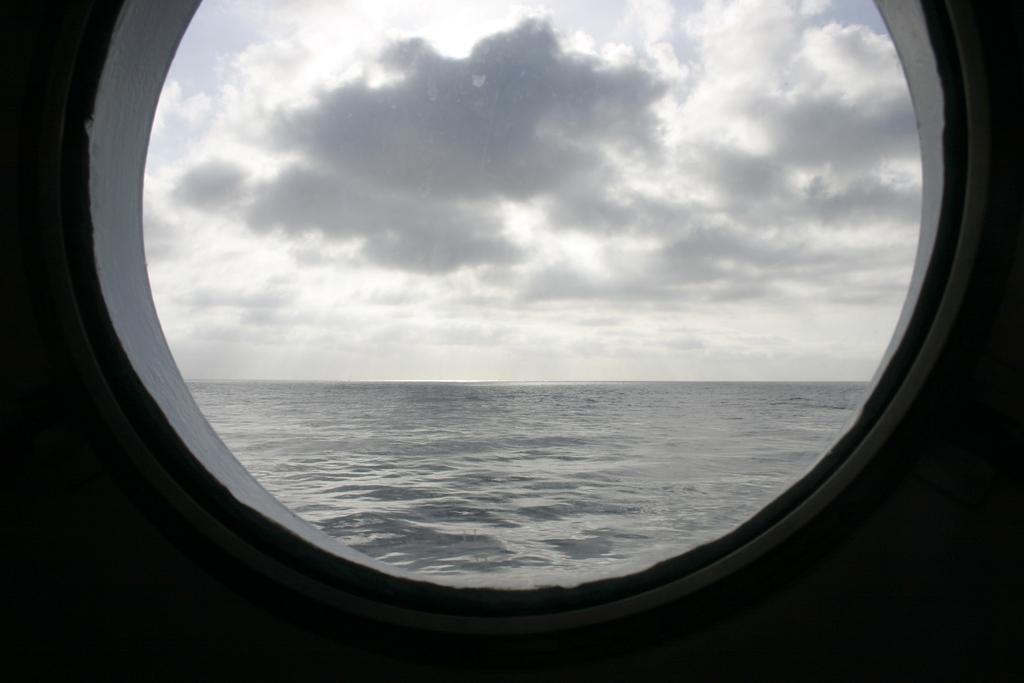What is located in the center of the image? There is a wall in the center of the image. What feature can be seen on the wall? There is a window in the wall. What can be seen through the window? The sky, clouds, and water are visible through the window. What type of jam is being spread on the vein in the image? There is no jam or vein present in the image. 